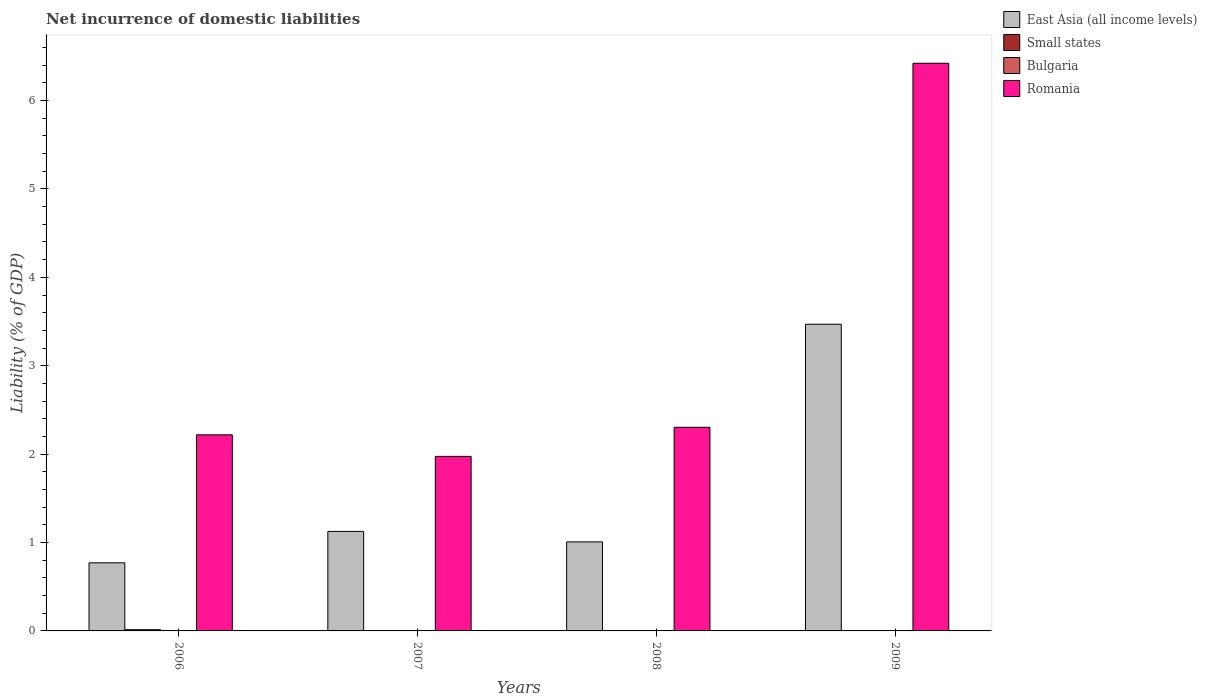How many different coloured bars are there?
Give a very brief answer. 3. How many groups of bars are there?
Your response must be concise. 4. Are the number of bars per tick equal to the number of legend labels?
Ensure brevity in your answer.  No. Are the number of bars on each tick of the X-axis equal?
Your response must be concise. No. How many bars are there on the 1st tick from the left?
Your answer should be compact. 3. What is the net incurrence of domestic liabilities in Small states in 2009?
Provide a short and direct response. 0. Across all years, what is the maximum net incurrence of domestic liabilities in Small states?
Provide a short and direct response. 0.01. Across all years, what is the minimum net incurrence of domestic liabilities in East Asia (all income levels)?
Your answer should be very brief. 0.77. In which year was the net incurrence of domestic liabilities in Romania maximum?
Your answer should be compact. 2009. What is the total net incurrence of domestic liabilities in Bulgaria in the graph?
Keep it short and to the point. 0. What is the difference between the net incurrence of domestic liabilities in Romania in 2007 and that in 2008?
Offer a terse response. -0.33. What is the difference between the net incurrence of domestic liabilities in Small states in 2008 and the net incurrence of domestic liabilities in Romania in 2007?
Offer a terse response. -1.97. In the year 2006, what is the difference between the net incurrence of domestic liabilities in Small states and net incurrence of domestic liabilities in Romania?
Provide a succinct answer. -2.2. In how many years, is the net incurrence of domestic liabilities in Romania greater than 3 %?
Keep it short and to the point. 1. What is the ratio of the net incurrence of domestic liabilities in Romania in 2006 to that in 2009?
Give a very brief answer. 0.35. What is the difference between the highest and the second highest net incurrence of domestic liabilities in East Asia (all income levels)?
Make the answer very short. 2.34. What is the difference between the highest and the lowest net incurrence of domestic liabilities in Small states?
Make the answer very short. 0.01. In how many years, is the net incurrence of domestic liabilities in Small states greater than the average net incurrence of domestic liabilities in Small states taken over all years?
Provide a succinct answer. 1. Is the sum of the net incurrence of domestic liabilities in East Asia (all income levels) in 2006 and 2008 greater than the maximum net incurrence of domestic liabilities in Bulgaria across all years?
Offer a terse response. Yes. Is it the case that in every year, the sum of the net incurrence of domestic liabilities in Bulgaria and net incurrence of domestic liabilities in East Asia (all income levels) is greater than the net incurrence of domestic liabilities in Romania?
Offer a terse response. No. How many years are there in the graph?
Your answer should be very brief. 4. What is the difference between two consecutive major ticks on the Y-axis?
Your answer should be compact. 1. Are the values on the major ticks of Y-axis written in scientific E-notation?
Your response must be concise. No. Where does the legend appear in the graph?
Your answer should be very brief. Top right. What is the title of the graph?
Your response must be concise. Net incurrence of domestic liabilities. What is the label or title of the Y-axis?
Provide a succinct answer. Liability (% of GDP). What is the Liability (% of GDP) of East Asia (all income levels) in 2006?
Offer a very short reply. 0.77. What is the Liability (% of GDP) of Small states in 2006?
Keep it short and to the point. 0.01. What is the Liability (% of GDP) of Bulgaria in 2006?
Your response must be concise. 0. What is the Liability (% of GDP) of Romania in 2006?
Ensure brevity in your answer.  2.22. What is the Liability (% of GDP) of East Asia (all income levels) in 2007?
Offer a very short reply. 1.13. What is the Liability (% of GDP) of Small states in 2007?
Offer a terse response. 0. What is the Liability (% of GDP) of Bulgaria in 2007?
Offer a terse response. 0. What is the Liability (% of GDP) of Romania in 2007?
Keep it short and to the point. 1.97. What is the Liability (% of GDP) in East Asia (all income levels) in 2008?
Provide a short and direct response. 1.01. What is the Liability (% of GDP) of Romania in 2008?
Your answer should be compact. 2.3. What is the Liability (% of GDP) in East Asia (all income levels) in 2009?
Ensure brevity in your answer.  3.47. What is the Liability (% of GDP) of Romania in 2009?
Keep it short and to the point. 6.42. Across all years, what is the maximum Liability (% of GDP) of East Asia (all income levels)?
Give a very brief answer. 3.47. Across all years, what is the maximum Liability (% of GDP) in Small states?
Offer a very short reply. 0.01. Across all years, what is the maximum Liability (% of GDP) in Romania?
Your answer should be very brief. 6.42. Across all years, what is the minimum Liability (% of GDP) of East Asia (all income levels)?
Ensure brevity in your answer.  0.77. Across all years, what is the minimum Liability (% of GDP) in Romania?
Offer a terse response. 1.97. What is the total Liability (% of GDP) in East Asia (all income levels) in the graph?
Your response must be concise. 6.37. What is the total Liability (% of GDP) of Small states in the graph?
Provide a short and direct response. 0.01. What is the total Liability (% of GDP) of Romania in the graph?
Provide a short and direct response. 12.92. What is the difference between the Liability (% of GDP) of East Asia (all income levels) in 2006 and that in 2007?
Make the answer very short. -0.36. What is the difference between the Liability (% of GDP) in Romania in 2006 and that in 2007?
Offer a very short reply. 0.24. What is the difference between the Liability (% of GDP) of East Asia (all income levels) in 2006 and that in 2008?
Offer a very short reply. -0.24. What is the difference between the Liability (% of GDP) in Romania in 2006 and that in 2008?
Provide a short and direct response. -0.09. What is the difference between the Liability (% of GDP) in East Asia (all income levels) in 2006 and that in 2009?
Provide a succinct answer. -2.7. What is the difference between the Liability (% of GDP) in Romania in 2006 and that in 2009?
Offer a very short reply. -4.2. What is the difference between the Liability (% of GDP) of East Asia (all income levels) in 2007 and that in 2008?
Your answer should be very brief. 0.12. What is the difference between the Liability (% of GDP) of Romania in 2007 and that in 2008?
Your response must be concise. -0.33. What is the difference between the Liability (% of GDP) in East Asia (all income levels) in 2007 and that in 2009?
Provide a succinct answer. -2.34. What is the difference between the Liability (% of GDP) in Romania in 2007 and that in 2009?
Keep it short and to the point. -4.45. What is the difference between the Liability (% of GDP) of East Asia (all income levels) in 2008 and that in 2009?
Give a very brief answer. -2.46. What is the difference between the Liability (% of GDP) in Romania in 2008 and that in 2009?
Your answer should be very brief. -4.12. What is the difference between the Liability (% of GDP) of East Asia (all income levels) in 2006 and the Liability (% of GDP) of Romania in 2007?
Provide a short and direct response. -1.2. What is the difference between the Liability (% of GDP) of Small states in 2006 and the Liability (% of GDP) of Romania in 2007?
Make the answer very short. -1.96. What is the difference between the Liability (% of GDP) of East Asia (all income levels) in 2006 and the Liability (% of GDP) of Romania in 2008?
Ensure brevity in your answer.  -1.53. What is the difference between the Liability (% of GDP) of Small states in 2006 and the Liability (% of GDP) of Romania in 2008?
Your answer should be very brief. -2.29. What is the difference between the Liability (% of GDP) of East Asia (all income levels) in 2006 and the Liability (% of GDP) of Romania in 2009?
Provide a short and direct response. -5.65. What is the difference between the Liability (% of GDP) in Small states in 2006 and the Liability (% of GDP) in Romania in 2009?
Your answer should be very brief. -6.41. What is the difference between the Liability (% of GDP) in East Asia (all income levels) in 2007 and the Liability (% of GDP) in Romania in 2008?
Keep it short and to the point. -1.18. What is the difference between the Liability (% of GDP) of East Asia (all income levels) in 2007 and the Liability (% of GDP) of Romania in 2009?
Provide a succinct answer. -5.3. What is the difference between the Liability (% of GDP) of East Asia (all income levels) in 2008 and the Liability (% of GDP) of Romania in 2009?
Your answer should be very brief. -5.41. What is the average Liability (% of GDP) in East Asia (all income levels) per year?
Your answer should be compact. 1.59. What is the average Liability (% of GDP) in Small states per year?
Give a very brief answer. 0. What is the average Liability (% of GDP) of Romania per year?
Provide a succinct answer. 3.23. In the year 2006, what is the difference between the Liability (% of GDP) of East Asia (all income levels) and Liability (% of GDP) of Small states?
Give a very brief answer. 0.76. In the year 2006, what is the difference between the Liability (% of GDP) in East Asia (all income levels) and Liability (% of GDP) in Romania?
Provide a succinct answer. -1.45. In the year 2006, what is the difference between the Liability (% of GDP) of Small states and Liability (% of GDP) of Romania?
Offer a very short reply. -2.2. In the year 2007, what is the difference between the Liability (% of GDP) in East Asia (all income levels) and Liability (% of GDP) in Romania?
Ensure brevity in your answer.  -0.85. In the year 2008, what is the difference between the Liability (% of GDP) in East Asia (all income levels) and Liability (% of GDP) in Romania?
Give a very brief answer. -1.3. In the year 2009, what is the difference between the Liability (% of GDP) of East Asia (all income levels) and Liability (% of GDP) of Romania?
Provide a short and direct response. -2.95. What is the ratio of the Liability (% of GDP) of East Asia (all income levels) in 2006 to that in 2007?
Your answer should be compact. 0.68. What is the ratio of the Liability (% of GDP) of Romania in 2006 to that in 2007?
Your answer should be compact. 1.12. What is the ratio of the Liability (% of GDP) in East Asia (all income levels) in 2006 to that in 2008?
Make the answer very short. 0.77. What is the ratio of the Liability (% of GDP) in Romania in 2006 to that in 2008?
Keep it short and to the point. 0.96. What is the ratio of the Liability (% of GDP) in East Asia (all income levels) in 2006 to that in 2009?
Ensure brevity in your answer.  0.22. What is the ratio of the Liability (% of GDP) of Romania in 2006 to that in 2009?
Offer a terse response. 0.35. What is the ratio of the Liability (% of GDP) of East Asia (all income levels) in 2007 to that in 2008?
Offer a very short reply. 1.12. What is the ratio of the Liability (% of GDP) in Romania in 2007 to that in 2008?
Ensure brevity in your answer.  0.86. What is the ratio of the Liability (% of GDP) of East Asia (all income levels) in 2007 to that in 2009?
Offer a very short reply. 0.32. What is the ratio of the Liability (% of GDP) of Romania in 2007 to that in 2009?
Provide a short and direct response. 0.31. What is the ratio of the Liability (% of GDP) of East Asia (all income levels) in 2008 to that in 2009?
Provide a short and direct response. 0.29. What is the ratio of the Liability (% of GDP) in Romania in 2008 to that in 2009?
Ensure brevity in your answer.  0.36. What is the difference between the highest and the second highest Liability (% of GDP) in East Asia (all income levels)?
Your answer should be very brief. 2.34. What is the difference between the highest and the second highest Liability (% of GDP) of Romania?
Offer a very short reply. 4.12. What is the difference between the highest and the lowest Liability (% of GDP) in East Asia (all income levels)?
Ensure brevity in your answer.  2.7. What is the difference between the highest and the lowest Liability (% of GDP) of Small states?
Give a very brief answer. 0.01. What is the difference between the highest and the lowest Liability (% of GDP) of Romania?
Give a very brief answer. 4.45. 